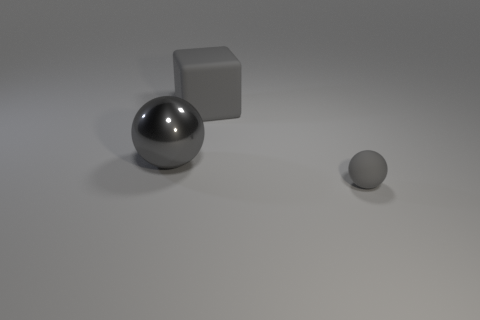Add 2 green matte things. How many objects exist? 5 Subtract all spheres. How many objects are left? 1 Add 1 cubes. How many cubes exist? 2 Subtract 0 yellow spheres. How many objects are left? 3 Subtract all large purple rubber balls. Subtract all rubber objects. How many objects are left? 1 Add 2 small gray rubber things. How many small gray rubber things are left? 3 